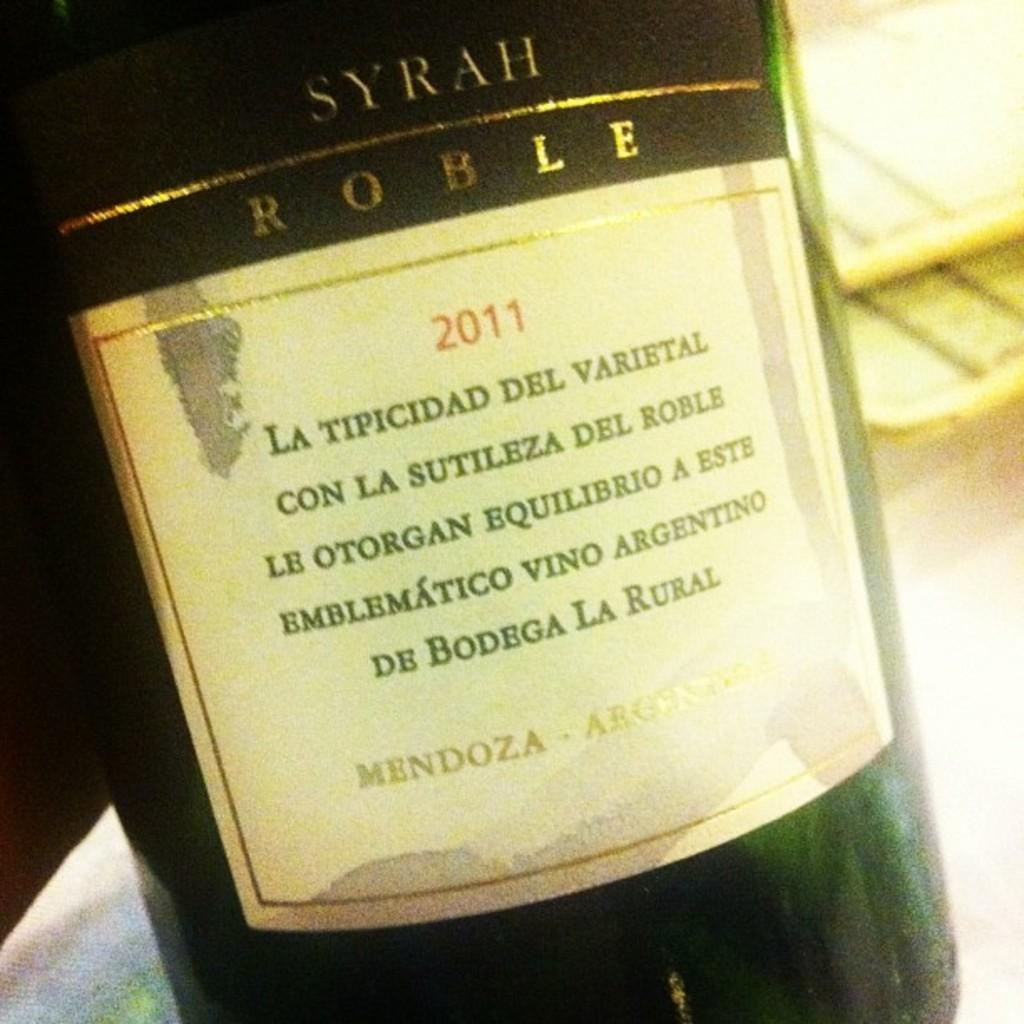<image>
Render a clear and concise summary of the photo. a bottle of 2011 Syrah from Mendoza Argentina 